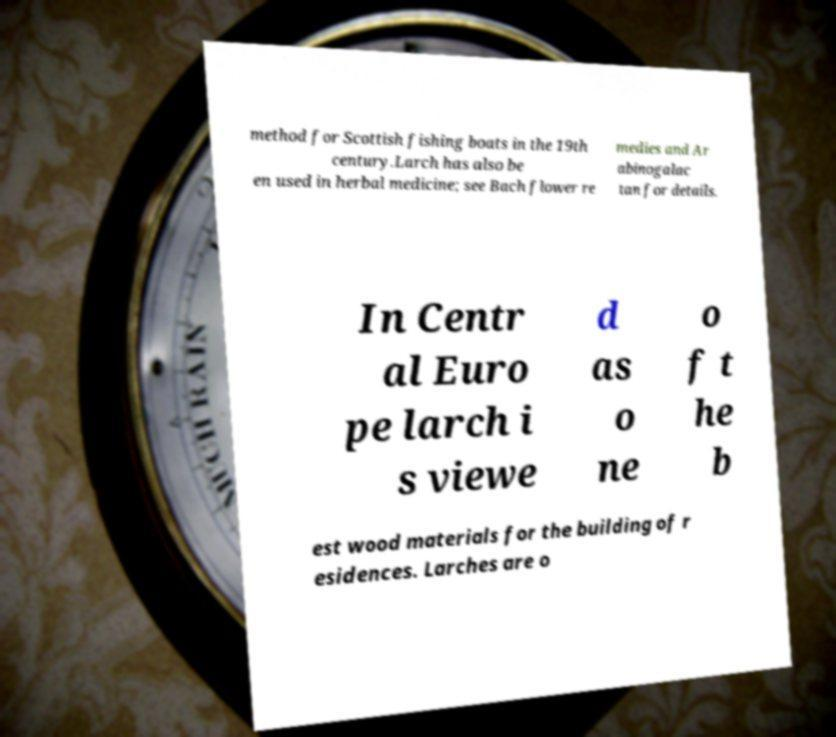Can you read and provide the text displayed in the image?This photo seems to have some interesting text. Can you extract and type it out for me? method for Scottish fishing boats in the 19th century.Larch has also be en used in herbal medicine; see Bach flower re medies and Ar abinogalac tan for details. In Centr al Euro pe larch i s viewe d as o ne o f t he b est wood materials for the building of r esidences. Larches are o 